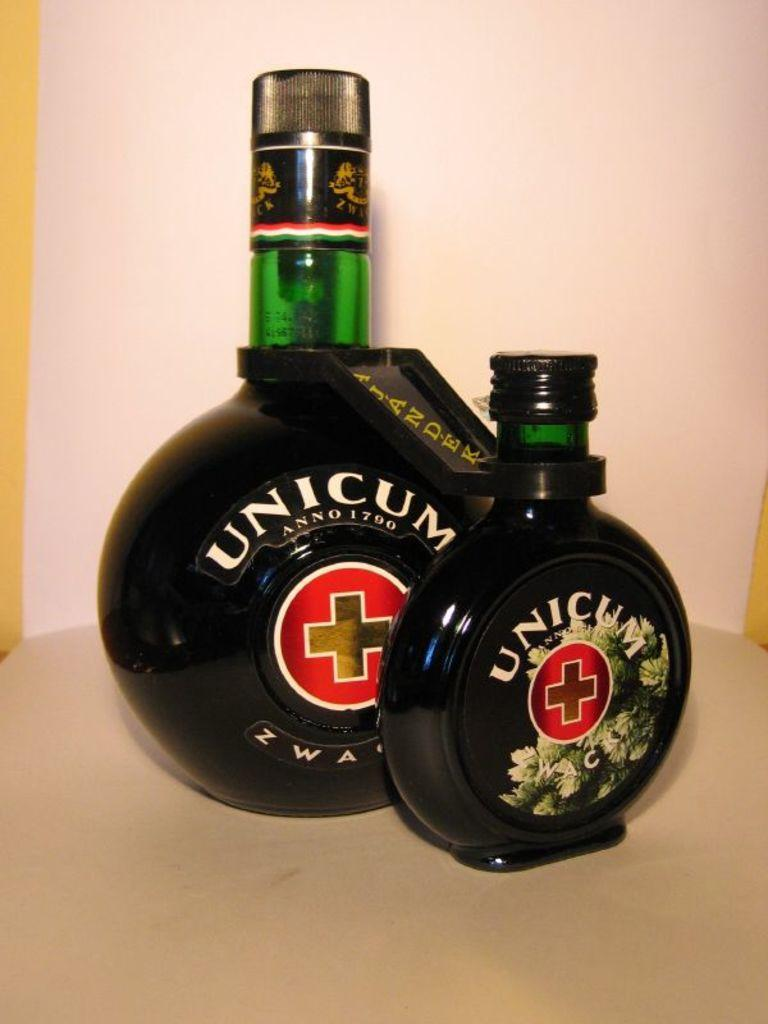<image>
Offer a succinct explanation of the picture presented. Two bottles of Unicum Anno 1790 sit on a table 